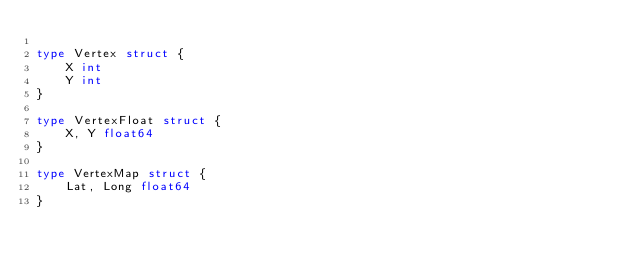<code> <loc_0><loc_0><loc_500><loc_500><_Go_>
type Vertex struct {
	X int
	Y int
}

type VertexFloat struct {
	X, Y float64
}

type VertexMap struct {
	Lat, Long float64
}
</code> 